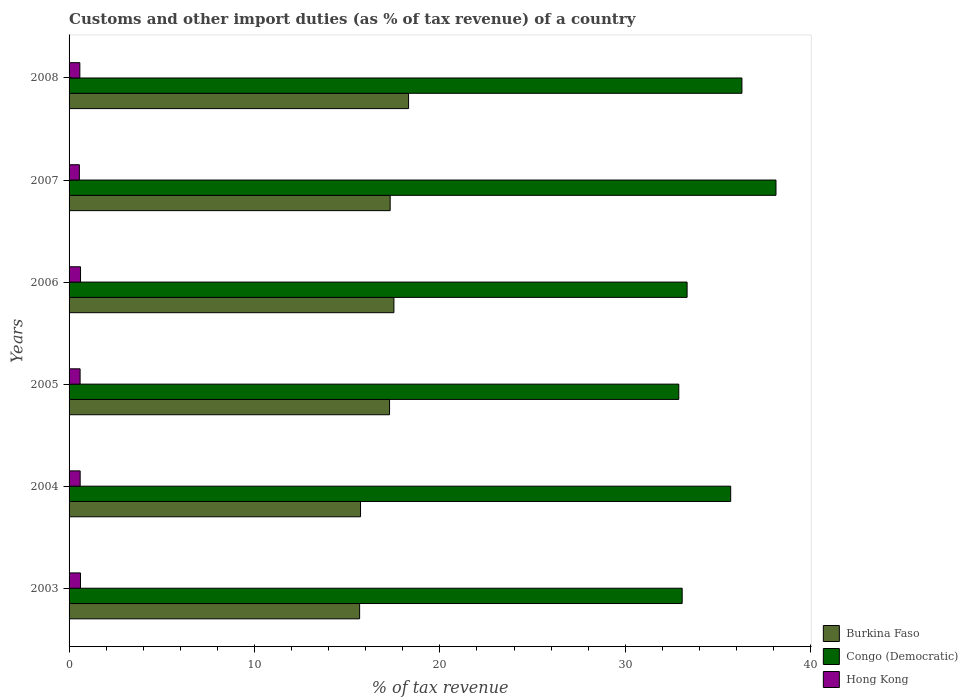How many different coloured bars are there?
Offer a terse response. 3. How many groups of bars are there?
Make the answer very short. 6. Are the number of bars per tick equal to the number of legend labels?
Ensure brevity in your answer.  Yes. Are the number of bars on each tick of the Y-axis equal?
Provide a short and direct response. Yes. How many bars are there on the 4th tick from the top?
Ensure brevity in your answer.  3. How many bars are there on the 2nd tick from the bottom?
Offer a terse response. 3. What is the label of the 6th group of bars from the top?
Offer a terse response. 2003. What is the percentage of tax revenue from customs in Congo (Democratic) in 2004?
Ensure brevity in your answer.  35.69. Across all years, what is the maximum percentage of tax revenue from customs in Congo (Democratic)?
Keep it short and to the point. 38.13. Across all years, what is the minimum percentage of tax revenue from customs in Hong Kong?
Provide a short and direct response. 0.56. In which year was the percentage of tax revenue from customs in Hong Kong minimum?
Your answer should be compact. 2007. What is the total percentage of tax revenue from customs in Burkina Faso in the graph?
Ensure brevity in your answer.  101.84. What is the difference between the percentage of tax revenue from customs in Burkina Faso in 2005 and that in 2007?
Ensure brevity in your answer.  -0.03. What is the difference between the percentage of tax revenue from customs in Congo (Democratic) in 2007 and the percentage of tax revenue from customs in Burkina Faso in 2003?
Your response must be concise. 22.46. What is the average percentage of tax revenue from customs in Burkina Faso per year?
Your answer should be compact. 16.97. In the year 2007, what is the difference between the percentage of tax revenue from customs in Hong Kong and percentage of tax revenue from customs in Burkina Faso?
Offer a very short reply. -16.76. In how many years, is the percentage of tax revenue from customs in Burkina Faso greater than 16 %?
Keep it short and to the point. 4. What is the ratio of the percentage of tax revenue from customs in Hong Kong in 2003 to that in 2004?
Ensure brevity in your answer.  1.03. Is the percentage of tax revenue from customs in Hong Kong in 2004 less than that in 2008?
Your response must be concise. No. What is the difference between the highest and the second highest percentage of tax revenue from customs in Burkina Faso?
Your answer should be compact. 0.79. What is the difference between the highest and the lowest percentage of tax revenue from customs in Hong Kong?
Offer a very short reply. 0.06. In how many years, is the percentage of tax revenue from customs in Hong Kong greater than the average percentage of tax revenue from customs in Hong Kong taken over all years?
Your answer should be compact. 4. Is the sum of the percentage of tax revenue from customs in Burkina Faso in 2005 and 2008 greater than the maximum percentage of tax revenue from customs in Congo (Democratic) across all years?
Make the answer very short. No. What does the 2nd bar from the top in 2006 represents?
Provide a short and direct response. Congo (Democratic). What does the 3rd bar from the bottom in 2004 represents?
Provide a short and direct response. Hong Kong. Is it the case that in every year, the sum of the percentage of tax revenue from customs in Hong Kong and percentage of tax revenue from customs in Congo (Democratic) is greater than the percentage of tax revenue from customs in Burkina Faso?
Keep it short and to the point. Yes. How many years are there in the graph?
Make the answer very short. 6. What is the difference between two consecutive major ticks on the X-axis?
Your answer should be compact. 10. Are the values on the major ticks of X-axis written in scientific E-notation?
Your answer should be very brief. No. Does the graph contain any zero values?
Make the answer very short. No. How many legend labels are there?
Keep it short and to the point. 3. What is the title of the graph?
Your response must be concise. Customs and other import duties (as % of tax revenue) of a country. What is the label or title of the X-axis?
Provide a succinct answer. % of tax revenue. What is the % of tax revenue in Burkina Faso in 2003?
Ensure brevity in your answer.  15.67. What is the % of tax revenue of Congo (Democratic) in 2003?
Make the answer very short. 33.07. What is the % of tax revenue of Hong Kong in 2003?
Provide a succinct answer. 0.61. What is the % of tax revenue in Burkina Faso in 2004?
Ensure brevity in your answer.  15.72. What is the % of tax revenue of Congo (Democratic) in 2004?
Ensure brevity in your answer.  35.69. What is the % of tax revenue of Hong Kong in 2004?
Keep it short and to the point. 0.6. What is the % of tax revenue of Burkina Faso in 2005?
Your answer should be very brief. 17.29. What is the % of tax revenue of Congo (Democratic) in 2005?
Your response must be concise. 32.89. What is the % of tax revenue of Hong Kong in 2005?
Your answer should be very brief. 0.59. What is the % of tax revenue in Burkina Faso in 2006?
Your response must be concise. 17.52. What is the % of tax revenue of Congo (Democratic) in 2006?
Offer a very short reply. 33.34. What is the % of tax revenue of Hong Kong in 2006?
Provide a short and direct response. 0.62. What is the % of tax revenue of Burkina Faso in 2007?
Ensure brevity in your answer.  17.32. What is the % of tax revenue in Congo (Democratic) in 2007?
Your response must be concise. 38.13. What is the % of tax revenue of Hong Kong in 2007?
Your answer should be compact. 0.56. What is the % of tax revenue of Burkina Faso in 2008?
Make the answer very short. 18.31. What is the % of tax revenue of Congo (Democratic) in 2008?
Offer a very short reply. 36.29. What is the % of tax revenue of Hong Kong in 2008?
Ensure brevity in your answer.  0.58. Across all years, what is the maximum % of tax revenue in Burkina Faso?
Offer a very short reply. 18.31. Across all years, what is the maximum % of tax revenue in Congo (Democratic)?
Make the answer very short. 38.13. Across all years, what is the maximum % of tax revenue of Hong Kong?
Your answer should be very brief. 0.62. Across all years, what is the minimum % of tax revenue in Burkina Faso?
Provide a short and direct response. 15.67. Across all years, what is the minimum % of tax revenue in Congo (Democratic)?
Your response must be concise. 32.89. Across all years, what is the minimum % of tax revenue in Hong Kong?
Make the answer very short. 0.56. What is the total % of tax revenue in Burkina Faso in the graph?
Your answer should be compact. 101.84. What is the total % of tax revenue of Congo (Democratic) in the graph?
Your answer should be compact. 209.41. What is the total % of tax revenue in Hong Kong in the graph?
Make the answer very short. 3.56. What is the difference between the % of tax revenue in Burkina Faso in 2003 and that in 2004?
Keep it short and to the point. -0.05. What is the difference between the % of tax revenue in Congo (Democratic) in 2003 and that in 2004?
Ensure brevity in your answer.  -2.62. What is the difference between the % of tax revenue in Hong Kong in 2003 and that in 2004?
Make the answer very short. 0.02. What is the difference between the % of tax revenue in Burkina Faso in 2003 and that in 2005?
Give a very brief answer. -1.61. What is the difference between the % of tax revenue of Congo (Democratic) in 2003 and that in 2005?
Provide a short and direct response. 0.18. What is the difference between the % of tax revenue of Hong Kong in 2003 and that in 2005?
Your answer should be compact. 0.02. What is the difference between the % of tax revenue in Burkina Faso in 2003 and that in 2006?
Offer a very short reply. -1.85. What is the difference between the % of tax revenue in Congo (Democratic) in 2003 and that in 2006?
Your answer should be compact. -0.26. What is the difference between the % of tax revenue of Hong Kong in 2003 and that in 2006?
Your answer should be compact. -0. What is the difference between the % of tax revenue of Burkina Faso in 2003 and that in 2007?
Give a very brief answer. -1.65. What is the difference between the % of tax revenue of Congo (Democratic) in 2003 and that in 2007?
Provide a succinct answer. -5.06. What is the difference between the % of tax revenue of Hong Kong in 2003 and that in 2007?
Keep it short and to the point. 0.06. What is the difference between the % of tax revenue in Burkina Faso in 2003 and that in 2008?
Give a very brief answer. -2.64. What is the difference between the % of tax revenue of Congo (Democratic) in 2003 and that in 2008?
Your answer should be compact. -3.22. What is the difference between the % of tax revenue of Burkina Faso in 2004 and that in 2005?
Provide a short and direct response. -1.57. What is the difference between the % of tax revenue in Congo (Democratic) in 2004 and that in 2005?
Your answer should be compact. 2.8. What is the difference between the % of tax revenue in Hong Kong in 2004 and that in 2005?
Make the answer very short. 0. What is the difference between the % of tax revenue in Burkina Faso in 2004 and that in 2006?
Make the answer very short. -1.8. What is the difference between the % of tax revenue of Congo (Democratic) in 2004 and that in 2006?
Ensure brevity in your answer.  2.35. What is the difference between the % of tax revenue in Hong Kong in 2004 and that in 2006?
Offer a very short reply. -0.02. What is the difference between the % of tax revenue in Burkina Faso in 2004 and that in 2007?
Give a very brief answer. -1.6. What is the difference between the % of tax revenue in Congo (Democratic) in 2004 and that in 2007?
Give a very brief answer. -2.44. What is the difference between the % of tax revenue in Hong Kong in 2004 and that in 2007?
Offer a terse response. 0.04. What is the difference between the % of tax revenue of Burkina Faso in 2004 and that in 2008?
Offer a terse response. -2.59. What is the difference between the % of tax revenue in Congo (Democratic) in 2004 and that in 2008?
Offer a terse response. -0.61. What is the difference between the % of tax revenue in Hong Kong in 2004 and that in 2008?
Your answer should be compact. 0.02. What is the difference between the % of tax revenue of Burkina Faso in 2005 and that in 2006?
Make the answer very short. -0.24. What is the difference between the % of tax revenue of Congo (Democratic) in 2005 and that in 2006?
Make the answer very short. -0.45. What is the difference between the % of tax revenue in Hong Kong in 2005 and that in 2006?
Offer a terse response. -0.02. What is the difference between the % of tax revenue in Burkina Faso in 2005 and that in 2007?
Give a very brief answer. -0.03. What is the difference between the % of tax revenue in Congo (Democratic) in 2005 and that in 2007?
Offer a very short reply. -5.24. What is the difference between the % of tax revenue of Hong Kong in 2005 and that in 2007?
Your answer should be compact. 0.04. What is the difference between the % of tax revenue in Burkina Faso in 2005 and that in 2008?
Provide a short and direct response. -1.03. What is the difference between the % of tax revenue of Congo (Democratic) in 2005 and that in 2008?
Provide a short and direct response. -3.4. What is the difference between the % of tax revenue of Hong Kong in 2005 and that in 2008?
Give a very brief answer. 0.01. What is the difference between the % of tax revenue of Burkina Faso in 2006 and that in 2007?
Your answer should be very brief. 0.2. What is the difference between the % of tax revenue of Congo (Democratic) in 2006 and that in 2007?
Offer a very short reply. -4.8. What is the difference between the % of tax revenue in Hong Kong in 2006 and that in 2007?
Offer a terse response. 0.06. What is the difference between the % of tax revenue in Burkina Faso in 2006 and that in 2008?
Offer a terse response. -0.79. What is the difference between the % of tax revenue of Congo (Democratic) in 2006 and that in 2008?
Offer a very short reply. -2.96. What is the difference between the % of tax revenue in Hong Kong in 2006 and that in 2008?
Ensure brevity in your answer.  0.04. What is the difference between the % of tax revenue of Burkina Faso in 2007 and that in 2008?
Make the answer very short. -0.99. What is the difference between the % of tax revenue in Congo (Democratic) in 2007 and that in 2008?
Keep it short and to the point. 1.84. What is the difference between the % of tax revenue in Hong Kong in 2007 and that in 2008?
Make the answer very short. -0.03. What is the difference between the % of tax revenue in Burkina Faso in 2003 and the % of tax revenue in Congo (Democratic) in 2004?
Ensure brevity in your answer.  -20.01. What is the difference between the % of tax revenue in Burkina Faso in 2003 and the % of tax revenue in Hong Kong in 2004?
Keep it short and to the point. 15.07. What is the difference between the % of tax revenue of Congo (Democratic) in 2003 and the % of tax revenue of Hong Kong in 2004?
Provide a succinct answer. 32.47. What is the difference between the % of tax revenue in Burkina Faso in 2003 and the % of tax revenue in Congo (Democratic) in 2005?
Ensure brevity in your answer.  -17.22. What is the difference between the % of tax revenue in Burkina Faso in 2003 and the % of tax revenue in Hong Kong in 2005?
Your response must be concise. 15.08. What is the difference between the % of tax revenue in Congo (Democratic) in 2003 and the % of tax revenue in Hong Kong in 2005?
Ensure brevity in your answer.  32.48. What is the difference between the % of tax revenue in Burkina Faso in 2003 and the % of tax revenue in Congo (Democratic) in 2006?
Make the answer very short. -17.66. What is the difference between the % of tax revenue in Burkina Faso in 2003 and the % of tax revenue in Hong Kong in 2006?
Your answer should be very brief. 15.05. What is the difference between the % of tax revenue in Congo (Democratic) in 2003 and the % of tax revenue in Hong Kong in 2006?
Your answer should be very brief. 32.45. What is the difference between the % of tax revenue in Burkina Faso in 2003 and the % of tax revenue in Congo (Democratic) in 2007?
Your answer should be very brief. -22.46. What is the difference between the % of tax revenue of Burkina Faso in 2003 and the % of tax revenue of Hong Kong in 2007?
Your answer should be compact. 15.12. What is the difference between the % of tax revenue of Congo (Democratic) in 2003 and the % of tax revenue of Hong Kong in 2007?
Your answer should be very brief. 32.52. What is the difference between the % of tax revenue in Burkina Faso in 2003 and the % of tax revenue in Congo (Democratic) in 2008?
Give a very brief answer. -20.62. What is the difference between the % of tax revenue in Burkina Faso in 2003 and the % of tax revenue in Hong Kong in 2008?
Make the answer very short. 15.09. What is the difference between the % of tax revenue of Congo (Democratic) in 2003 and the % of tax revenue of Hong Kong in 2008?
Provide a short and direct response. 32.49. What is the difference between the % of tax revenue of Burkina Faso in 2004 and the % of tax revenue of Congo (Democratic) in 2005?
Provide a succinct answer. -17.17. What is the difference between the % of tax revenue of Burkina Faso in 2004 and the % of tax revenue of Hong Kong in 2005?
Provide a succinct answer. 15.13. What is the difference between the % of tax revenue in Congo (Democratic) in 2004 and the % of tax revenue in Hong Kong in 2005?
Provide a succinct answer. 35.09. What is the difference between the % of tax revenue in Burkina Faso in 2004 and the % of tax revenue in Congo (Democratic) in 2006?
Provide a succinct answer. -17.61. What is the difference between the % of tax revenue of Burkina Faso in 2004 and the % of tax revenue of Hong Kong in 2006?
Offer a terse response. 15.1. What is the difference between the % of tax revenue in Congo (Democratic) in 2004 and the % of tax revenue in Hong Kong in 2006?
Make the answer very short. 35.07. What is the difference between the % of tax revenue of Burkina Faso in 2004 and the % of tax revenue of Congo (Democratic) in 2007?
Provide a short and direct response. -22.41. What is the difference between the % of tax revenue of Burkina Faso in 2004 and the % of tax revenue of Hong Kong in 2007?
Your answer should be very brief. 15.17. What is the difference between the % of tax revenue of Congo (Democratic) in 2004 and the % of tax revenue of Hong Kong in 2007?
Your response must be concise. 35.13. What is the difference between the % of tax revenue in Burkina Faso in 2004 and the % of tax revenue in Congo (Democratic) in 2008?
Offer a terse response. -20.57. What is the difference between the % of tax revenue of Burkina Faso in 2004 and the % of tax revenue of Hong Kong in 2008?
Ensure brevity in your answer.  15.14. What is the difference between the % of tax revenue in Congo (Democratic) in 2004 and the % of tax revenue in Hong Kong in 2008?
Provide a succinct answer. 35.11. What is the difference between the % of tax revenue in Burkina Faso in 2005 and the % of tax revenue in Congo (Democratic) in 2006?
Your response must be concise. -16.05. What is the difference between the % of tax revenue of Burkina Faso in 2005 and the % of tax revenue of Hong Kong in 2006?
Make the answer very short. 16.67. What is the difference between the % of tax revenue of Congo (Democratic) in 2005 and the % of tax revenue of Hong Kong in 2006?
Give a very brief answer. 32.27. What is the difference between the % of tax revenue in Burkina Faso in 2005 and the % of tax revenue in Congo (Democratic) in 2007?
Offer a very short reply. -20.84. What is the difference between the % of tax revenue in Burkina Faso in 2005 and the % of tax revenue in Hong Kong in 2007?
Your answer should be compact. 16.73. What is the difference between the % of tax revenue in Congo (Democratic) in 2005 and the % of tax revenue in Hong Kong in 2007?
Your answer should be compact. 32.33. What is the difference between the % of tax revenue of Burkina Faso in 2005 and the % of tax revenue of Congo (Democratic) in 2008?
Your answer should be very brief. -19.01. What is the difference between the % of tax revenue in Burkina Faso in 2005 and the % of tax revenue in Hong Kong in 2008?
Provide a short and direct response. 16.71. What is the difference between the % of tax revenue in Congo (Democratic) in 2005 and the % of tax revenue in Hong Kong in 2008?
Provide a short and direct response. 32.31. What is the difference between the % of tax revenue of Burkina Faso in 2006 and the % of tax revenue of Congo (Democratic) in 2007?
Keep it short and to the point. -20.61. What is the difference between the % of tax revenue in Burkina Faso in 2006 and the % of tax revenue in Hong Kong in 2007?
Keep it short and to the point. 16.97. What is the difference between the % of tax revenue in Congo (Democratic) in 2006 and the % of tax revenue in Hong Kong in 2007?
Your answer should be very brief. 32.78. What is the difference between the % of tax revenue in Burkina Faso in 2006 and the % of tax revenue in Congo (Democratic) in 2008?
Provide a succinct answer. -18.77. What is the difference between the % of tax revenue in Burkina Faso in 2006 and the % of tax revenue in Hong Kong in 2008?
Keep it short and to the point. 16.94. What is the difference between the % of tax revenue in Congo (Democratic) in 2006 and the % of tax revenue in Hong Kong in 2008?
Your answer should be compact. 32.75. What is the difference between the % of tax revenue of Burkina Faso in 2007 and the % of tax revenue of Congo (Democratic) in 2008?
Make the answer very short. -18.97. What is the difference between the % of tax revenue of Burkina Faso in 2007 and the % of tax revenue of Hong Kong in 2008?
Your response must be concise. 16.74. What is the difference between the % of tax revenue in Congo (Democratic) in 2007 and the % of tax revenue in Hong Kong in 2008?
Provide a short and direct response. 37.55. What is the average % of tax revenue of Burkina Faso per year?
Offer a terse response. 16.97. What is the average % of tax revenue of Congo (Democratic) per year?
Keep it short and to the point. 34.9. What is the average % of tax revenue of Hong Kong per year?
Ensure brevity in your answer.  0.59. In the year 2003, what is the difference between the % of tax revenue in Burkina Faso and % of tax revenue in Congo (Democratic)?
Your response must be concise. -17.4. In the year 2003, what is the difference between the % of tax revenue of Burkina Faso and % of tax revenue of Hong Kong?
Provide a short and direct response. 15.06. In the year 2003, what is the difference between the % of tax revenue of Congo (Democratic) and % of tax revenue of Hong Kong?
Offer a very short reply. 32.46. In the year 2004, what is the difference between the % of tax revenue in Burkina Faso and % of tax revenue in Congo (Democratic)?
Give a very brief answer. -19.97. In the year 2004, what is the difference between the % of tax revenue in Burkina Faso and % of tax revenue in Hong Kong?
Keep it short and to the point. 15.12. In the year 2004, what is the difference between the % of tax revenue in Congo (Democratic) and % of tax revenue in Hong Kong?
Offer a very short reply. 35.09. In the year 2005, what is the difference between the % of tax revenue in Burkina Faso and % of tax revenue in Congo (Democratic)?
Make the answer very short. -15.6. In the year 2005, what is the difference between the % of tax revenue of Burkina Faso and % of tax revenue of Hong Kong?
Offer a very short reply. 16.69. In the year 2005, what is the difference between the % of tax revenue in Congo (Democratic) and % of tax revenue in Hong Kong?
Your answer should be very brief. 32.29. In the year 2006, what is the difference between the % of tax revenue of Burkina Faso and % of tax revenue of Congo (Democratic)?
Give a very brief answer. -15.81. In the year 2006, what is the difference between the % of tax revenue of Burkina Faso and % of tax revenue of Hong Kong?
Ensure brevity in your answer.  16.9. In the year 2006, what is the difference between the % of tax revenue in Congo (Democratic) and % of tax revenue in Hong Kong?
Offer a terse response. 32.72. In the year 2007, what is the difference between the % of tax revenue of Burkina Faso and % of tax revenue of Congo (Democratic)?
Provide a short and direct response. -20.81. In the year 2007, what is the difference between the % of tax revenue in Burkina Faso and % of tax revenue in Hong Kong?
Keep it short and to the point. 16.76. In the year 2007, what is the difference between the % of tax revenue of Congo (Democratic) and % of tax revenue of Hong Kong?
Give a very brief answer. 37.58. In the year 2008, what is the difference between the % of tax revenue of Burkina Faso and % of tax revenue of Congo (Democratic)?
Your answer should be compact. -17.98. In the year 2008, what is the difference between the % of tax revenue in Burkina Faso and % of tax revenue in Hong Kong?
Ensure brevity in your answer.  17.73. In the year 2008, what is the difference between the % of tax revenue of Congo (Democratic) and % of tax revenue of Hong Kong?
Keep it short and to the point. 35.71. What is the ratio of the % of tax revenue in Burkina Faso in 2003 to that in 2004?
Give a very brief answer. 1. What is the ratio of the % of tax revenue of Congo (Democratic) in 2003 to that in 2004?
Your answer should be compact. 0.93. What is the ratio of the % of tax revenue of Hong Kong in 2003 to that in 2004?
Keep it short and to the point. 1.03. What is the ratio of the % of tax revenue of Burkina Faso in 2003 to that in 2005?
Ensure brevity in your answer.  0.91. What is the ratio of the % of tax revenue in Congo (Democratic) in 2003 to that in 2005?
Offer a very short reply. 1.01. What is the ratio of the % of tax revenue of Hong Kong in 2003 to that in 2005?
Make the answer very short. 1.03. What is the ratio of the % of tax revenue in Burkina Faso in 2003 to that in 2006?
Your answer should be compact. 0.89. What is the ratio of the % of tax revenue of Congo (Democratic) in 2003 to that in 2006?
Give a very brief answer. 0.99. What is the ratio of the % of tax revenue in Hong Kong in 2003 to that in 2006?
Your answer should be compact. 0.99. What is the ratio of the % of tax revenue of Burkina Faso in 2003 to that in 2007?
Give a very brief answer. 0.9. What is the ratio of the % of tax revenue in Congo (Democratic) in 2003 to that in 2007?
Your response must be concise. 0.87. What is the ratio of the % of tax revenue of Hong Kong in 2003 to that in 2007?
Your response must be concise. 1.11. What is the ratio of the % of tax revenue in Burkina Faso in 2003 to that in 2008?
Provide a short and direct response. 0.86. What is the ratio of the % of tax revenue in Congo (Democratic) in 2003 to that in 2008?
Make the answer very short. 0.91. What is the ratio of the % of tax revenue of Hong Kong in 2003 to that in 2008?
Your answer should be very brief. 1.06. What is the ratio of the % of tax revenue in Burkina Faso in 2004 to that in 2005?
Keep it short and to the point. 0.91. What is the ratio of the % of tax revenue in Congo (Democratic) in 2004 to that in 2005?
Ensure brevity in your answer.  1.09. What is the ratio of the % of tax revenue of Hong Kong in 2004 to that in 2005?
Give a very brief answer. 1.01. What is the ratio of the % of tax revenue of Burkina Faso in 2004 to that in 2006?
Offer a terse response. 0.9. What is the ratio of the % of tax revenue in Congo (Democratic) in 2004 to that in 2006?
Your answer should be compact. 1.07. What is the ratio of the % of tax revenue in Hong Kong in 2004 to that in 2006?
Provide a short and direct response. 0.97. What is the ratio of the % of tax revenue in Burkina Faso in 2004 to that in 2007?
Give a very brief answer. 0.91. What is the ratio of the % of tax revenue in Congo (Democratic) in 2004 to that in 2007?
Ensure brevity in your answer.  0.94. What is the ratio of the % of tax revenue in Hong Kong in 2004 to that in 2007?
Offer a very short reply. 1.08. What is the ratio of the % of tax revenue of Burkina Faso in 2004 to that in 2008?
Provide a succinct answer. 0.86. What is the ratio of the % of tax revenue of Congo (Democratic) in 2004 to that in 2008?
Ensure brevity in your answer.  0.98. What is the ratio of the % of tax revenue of Hong Kong in 2004 to that in 2008?
Your answer should be very brief. 1.03. What is the ratio of the % of tax revenue of Burkina Faso in 2005 to that in 2006?
Provide a succinct answer. 0.99. What is the ratio of the % of tax revenue in Congo (Democratic) in 2005 to that in 2006?
Your response must be concise. 0.99. What is the ratio of the % of tax revenue of Hong Kong in 2005 to that in 2006?
Offer a terse response. 0.96. What is the ratio of the % of tax revenue in Congo (Democratic) in 2005 to that in 2007?
Offer a very short reply. 0.86. What is the ratio of the % of tax revenue of Hong Kong in 2005 to that in 2007?
Provide a short and direct response. 1.07. What is the ratio of the % of tax revenue of Burkina Faso in 2005 to that in 2008?
Provide a short and direct response. 0.94. What is the ratio of the % of tax revenue of Congo (Democratic) in 2005 to that in 2008?
Make the answer very short. 0.91. What is the ratio of the % of tax revenue of Hong Kong in 2005 to that in 2008?
Keep it short and to the point. 1.02. What is the ratio of the % of tax revenue of Burkina Faso in 2006 to that in 2007?
Make the answer very short. 1.01. What is the ratio of the % of tax revenue in Congo (Democratic) in 2006 to that in 2007?
Make the answer very short. 0.87. What is the ratio of the % of tax revenue in Hong Kong in 2006 to that in 2007?
Provide a short and direct response. 1.11. What is the ratio of the % of tax revenue of Burkina Faso in 2006 to that in 2008?
Your response must be concise. 0.96. What is the ratio of the % of tax revenue of Congo (Democratic) in 2006 to that in 2008?
Give a very brief answer. 0.92. What is the ratio of the % of tax revenue in Hong Kong in 2006 to that in 2008?
Your response must be concise. 1.06. What is the ratio of the % of tax revenue in Burkina Faso in 2007 to that in 2008?
Make the answer very short. 0.95. What is the ratio of the % of tax revenue of Congo (Democratic) in 2007 to that in 2008?
Keep it short and to the point. 1.05. What is the ratio of the % of tax revenue in Hong Kong in 2007 to that in 2008?
Ensure brevity in your answer.  0.96. What is the difference between the highest and the second highest % of tax revenue in Burkina Faso?
Your response must be concise. 0.79. What is the difference between the highest and the second highest % of tax revenue of Congo (Democratic)?
Your response must be concise. 1.84. What is the difference between the highest and the second highest % of tax revenue in Hong Kong?
Ensure brevity in your answer.  0. What is the difference between the highest and the lowest % of tax revenue in Burkina Faso?
Offer a terse response. 2.64. What is the difference between the highest and the lowest % of tax revenue in Congo (Democratic)?
Keep it short and to the point. 5.24. What is the difference between the highest and the lowest % of tax revenue of Hong Kong?
Your answer should be very brief. 0.06. 